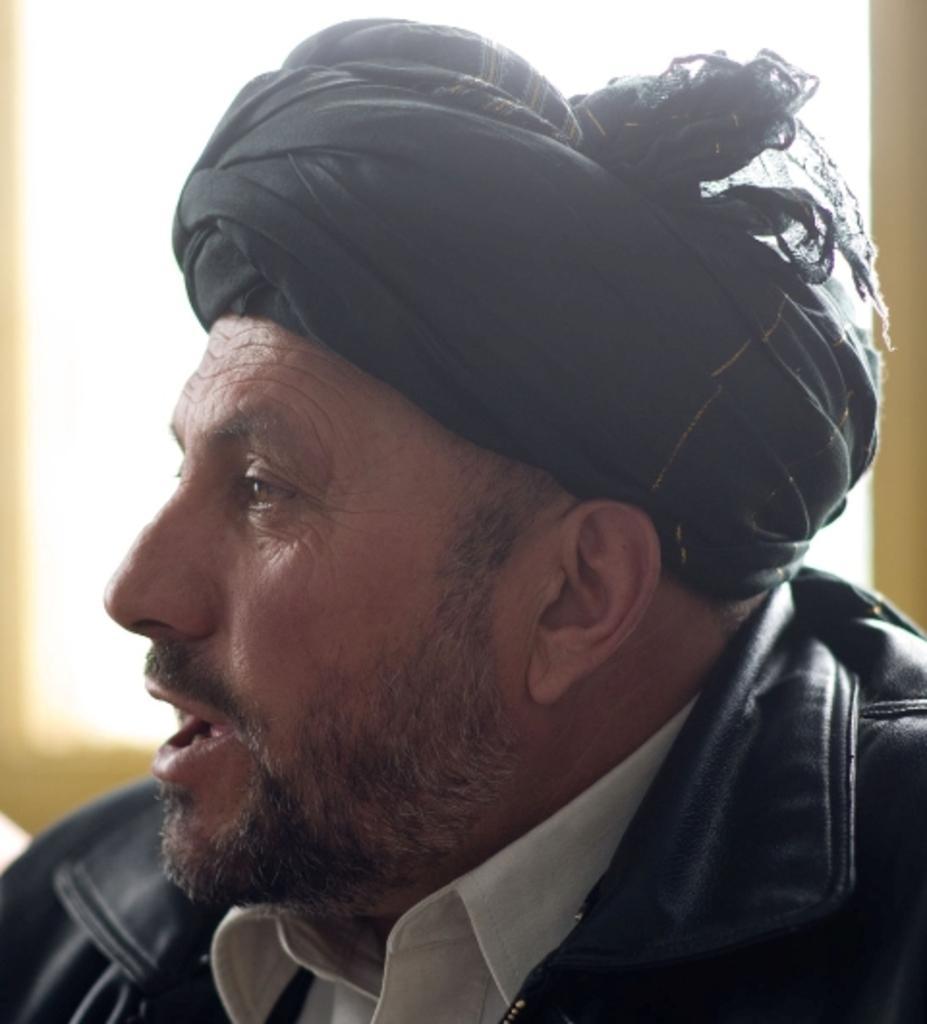In one or two sentences, can you explain what this image depicts? In this image we can see a man. 